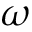<formula> <loc_0><loc_0><loc_500><loc_500>\omega</formula> 